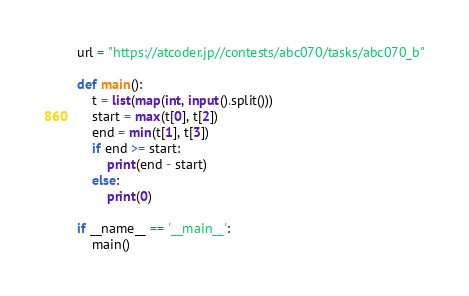Convert code to text. <code><loc_0><loc_0><loc_500><loc_500><_Python_>
url = "https://atcoder.jp//contests/abc070/tasks/abc070_b"

def main():
    t = list(map(int, input().split()))
    start = max(t[0], t[2])
    end = min(t[1], t[3])
    if end >= start:
        print(end - start)
    else:
        print(0)

if __name__ == '__main__':
    main()
</code> 